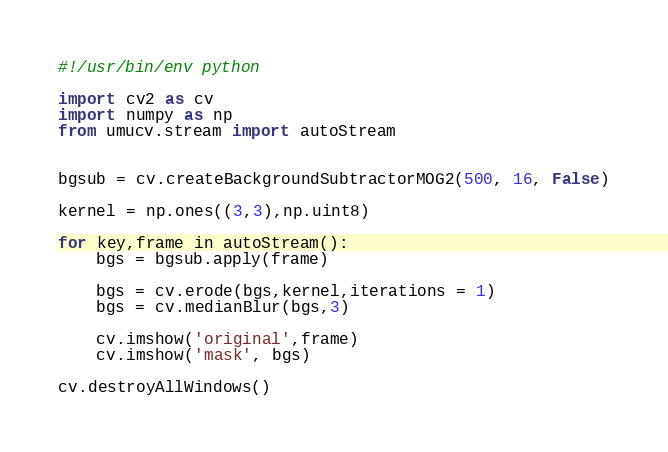<code> <loc_0><loc_0><loc_500><loc_500><_Python_>#!/usr/bin/env python

import cv2 as cv
import numpy as np
from umucv.stream import autoStream


bgsub = cv.createBackgroundSubtractorMOG2(500, 16, False)

kernel = np.ones((3,3),np.uint8)

for key,frame in autoStream():
    bgs = bgsub.apply(frame)
    
    bgs = cv.erode(bgs,kernel,iterations = 1)
    bgs = cv.medianBlur(bgs,3)

    cv.imshow('original',frame)
    cv.imshow('mask', bgs)

cv.destroyAllWindows()

</code> 